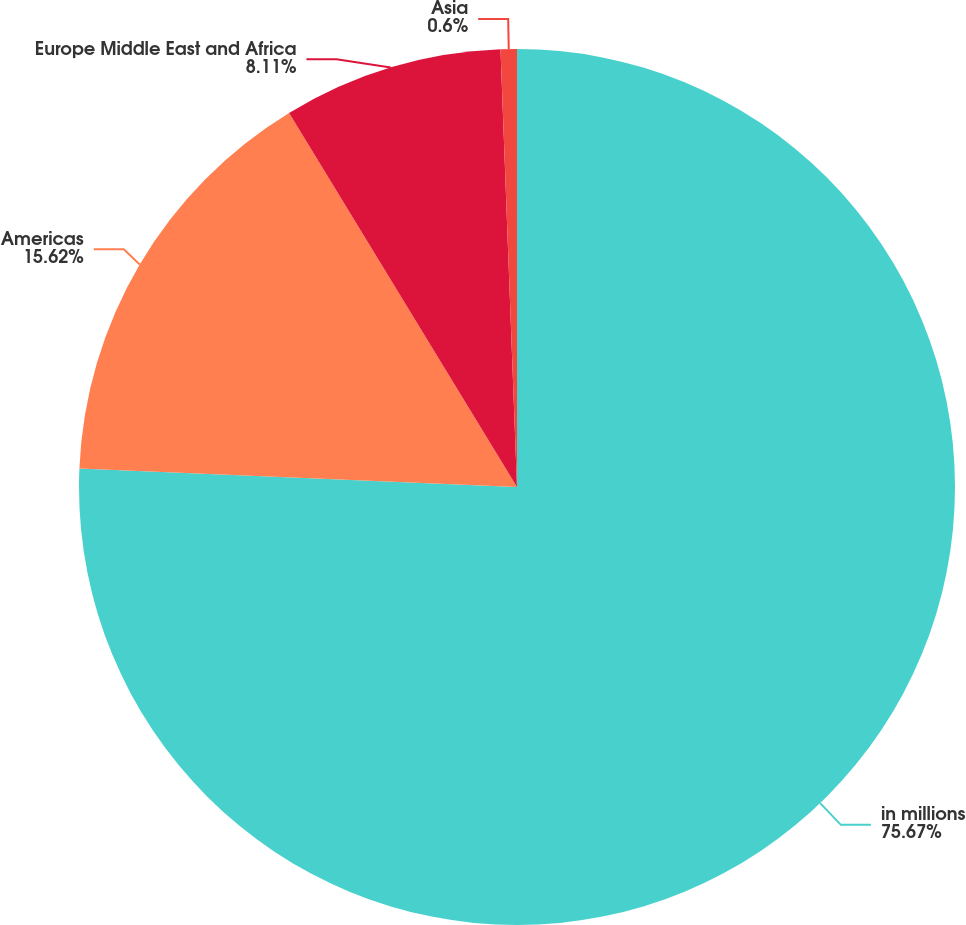Convert chart to OTSL. <chart><loc_0><loc_0><loc_500><loc_500><pie_chart><fcel>in millions<fcel>Americas<fcel>Europe Middle East and Africa<fcel>Asia<nl><fcel>75.67%<fcel>15.62%<fcel>8.11%<fcel>0.6%<nl></chart> 